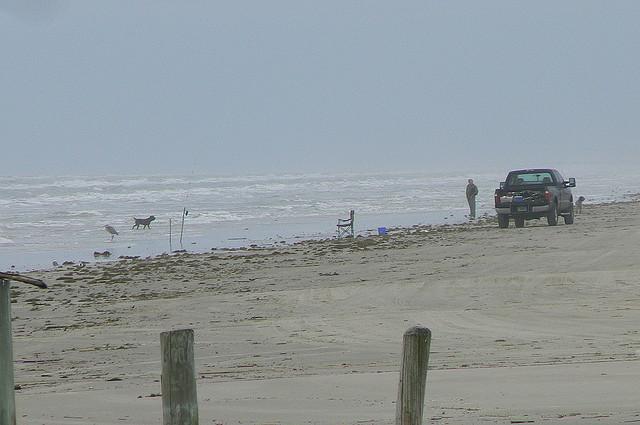How many animals are in the water?
Quick response, please. 2. Is this a dry place?
Concise answer only. No. Is this a beach?
Quick response, please. Yes. Is it cloudy or sunny?
Quick response, please. Cloudy. Has it snowed recently?
Be succinct. No. Black and white?
Short answer required. No. How many birds are in the photo?
Quick response, please. 1. Is this picture from Cancun, Mexico?
Concise answer only. No. What is the ground consisting of?
Give a very brief answer. Sand. Is it cold outside?
Be succinct. Yes. Is that a chair on the beach?
Give a very brief answer. Yes. What is the white stuff on the ground?
Give a very brief answer. Sand. Is it cold?
Give a very brief answer. Yes. Is the body of water a lake or ocean?
Be succinct. Ocean. Is this a lonely beach?
Give a very brief answer. Yes. 